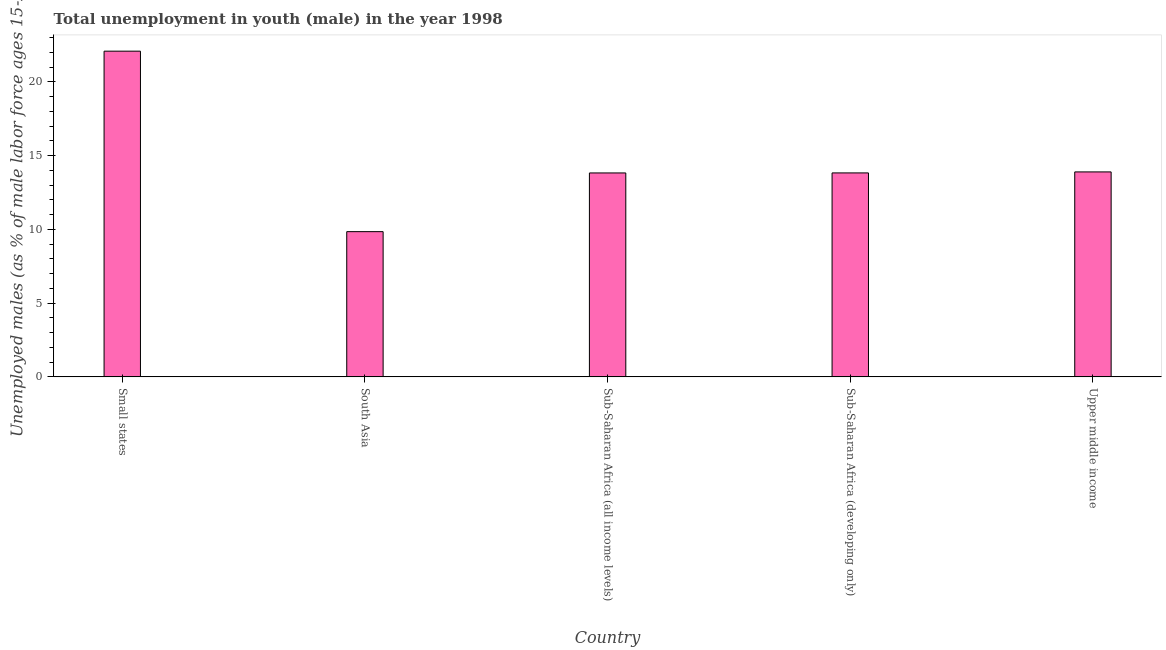Does the graph contain any zero values?
Give a very brief answer. No. Does the graph contain grids?
Give a very brief answer. No. What is the title of the graph?
Your response must be concise. Total unemployment in youth (male) in the year 1998. What is the label or title of the X-axis?
Provide a succinct answer. Country. What is the label or title of the Y-axis?
Your response must be concise. Unemployed males (as % of male labor force ages 15-24). What is the unemployed male youth population in Upper middle income?
Provide a short and direct response. 13.89. Across all countries, what is the maximum unemployed male youth population?
Provide a short and direct response. 22.08. Across all countries, what is the minimum unemployed male youth population?
Your answer should be compact. 9.84. In which country was the unemployed male youth population maximum?
Ensure brevity in your answer.  Small states. What is the sum of the unemployed male youth population?
Provide a succinct answer. 73.46. What is the difference between the unemployed male youth population in Sub-Saharan Africa (all income levels) and Sub-Saharan Africa (developing only)?
Provide a succinct answer. -0. What is the average unemployed male youth population per country?
Ensure brevity in your answer.  14.69. What is the median unemployed male youth population?
Make the answer very short. 13.82. What is the ratio of the unemployed male youth population in South Asia to that in Sub-Saharan Africa (developing only)?
Keep it short and to the point. 0.71. Is the unemployed male youth population in Sub-Saharan Africa (all income levels) less than that in Sub-Saharan Africa (developing only)?
Ensure brevity in your answer.  Yes. What is the difference between the highest and the second highest unemployed male youth population?
Your answer should be compact. 8.19. Is the sum of the unemployed male youth population in Small states and Sub-Saharan Africa (all income levels) greater than the maximum unemployed male youth population across all countries?
Offer a terse response. Yes. What is the difference between the highest and the lowest unemployed male youth population?
Offer a terse response. 12.23. In how many countries, is the unemployed male youth population greater than the average unemployed male youth population taken over all countries?
Give a very brief answer. 1. How many bars are there?
Offer a terse response. 5. How many countries are there in the graph?
Offer a very short reply. 5. What is the Unemployed males (as % of male labor force ages 15-24) of Small states?
Offer a terse response. 22.08. What is the Unemployed males (as % of male labor force ages 15-24) of South Asia?
Your answer should be very brief. 9.84. What is the Unemployed males (as % of male labor force ages 15-24) of Sub-Saharan Africa (all income levels)?
Your answer should be very brief. 13.82. What is the Unemployed males (as % of male labor force ages 15-24) in Sub-Saharan Africa (developing only)?
Make the answer very short. 13.82. What is the Unemployed males (as % of male labor force ages 15-24) in Upper middle income?
Give a very brief answer. 13.89. What is the difference between the Unemployed males (as % of male labor force ages 15-24) in Small states and South Asia?
Offer a terse response. 12.23. What is the difference between the Unemployed males (as % of male labor force ages 15-24) in Small states and Sub-Saharan Africa (all income levels)?
Provide a succinct answer. 8.25. What is the difference between the Unemployed males (as % of male labor force ages 15-24) in Small states and Sub-Saharan Africa (developing only)?
Provide a succinct answer. 8.25. What is the difference between the Unemployed males (as % of male labor force ages 15-24) in Small states and Upper middle income?
Provide a short and direct response. 8.18. What is the difference between the Unemployed males (as % of male labor force ages 15-24) in South Asia and Sub-Saharan Africa (all income levels)?
Make the answer very short. -3.98. What is the difference between the Unemployed males (as % of male labor force ages 15-24) in South Asia and Sub-Saharan Africa (developing only)?
Ensure brevity in your answer.  -3.98. What is the difference between the Unemployed males (as % of male labor force ages 15-24) in South Asia and Upper middle income?
Offer a terse response. -4.05. What is the difference between the Unemployed males (as % of male labor force ages 15-24) in Sub-Saharan Africa (all income levels) and Sub-Saharan Africa (developing only)?
Your answer should be compact. -0. What is the difference between the Unemployed males (as % of male labor force ages 15-24) in Sub-Saharan Africa (all income levels) and Upper middle income?
Keep it short and to the point. -0.07. What is the difference between the Unemployed males (as % of male labor force ages 15-24) in Sub-Saharan Africa (developing only) and Upper middle income?
Provide a succinct answer. -0.07. What is the ratio of the Unemployed males (as % of male labor force ages 15-24) in Small states to that in South Asia?
Your answer should be compact. 2.24. What is the ratio of the Unemployed males (as % of male labor force ages 15-24) in Small states to that in Sub-Saharan Africa (all income levels)?
Provide a short and direct response. 1.6. What is the ratio of the Unemployed males (as % of male labor force ages 15-24) in Small states to that in Sub-Saharan Africa (developing only)?
Your response must be concise. 1.6. What is the ratio of the Unemployed males (as % of male labor force ages 15-24) in Small states to that in Upper middle income?
Your answer should be compact. 1.59. What is the ratio of the Unemployed males (as % of male labor force ages 15-24) in South Asia to that in Sub-Saharan Africa (all income levels)?
Your answer should be compact. 0.71. What is the ratio of the Unemployed males (as % of male labor force ages 15-24) in South Asia to that in Sub-Saharan Africa (developing only)?
Offer a very short reply. 0.71. What is the ratio of the Unemployed males (as % of male labor force ages 15-24) in South Asia to that in Upper middle income?
Offer a terse response. 0.71. What is the ratio of the Unemployed males (as % of male labor force ages 15-24) in Sub-Saharan Africa (all income levels) to that in Upper middle income?
Your answer should be very brief. 0.99. 